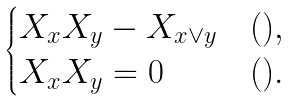Convert formula to latex. <formula><loc_0><loc_0><loc_500><loc_500>\begin{cases} X _ { x } X _ { y } - X _ { x \vee y } & ( ) , \\ X _ { x } X _ { y } = 0 & ( ) . \end{cases}</formula> 